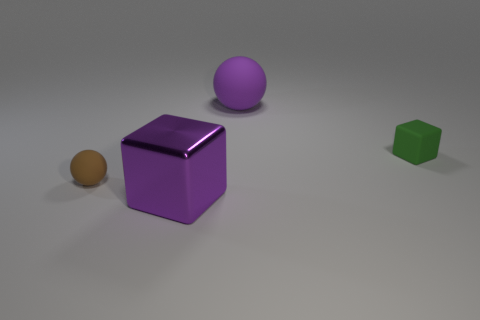There is a small matte object left of the ball on the right side of the brown ball; what shape is it? The small object to the left of the ball on the right side, which is near the brown ball, is a cube. 